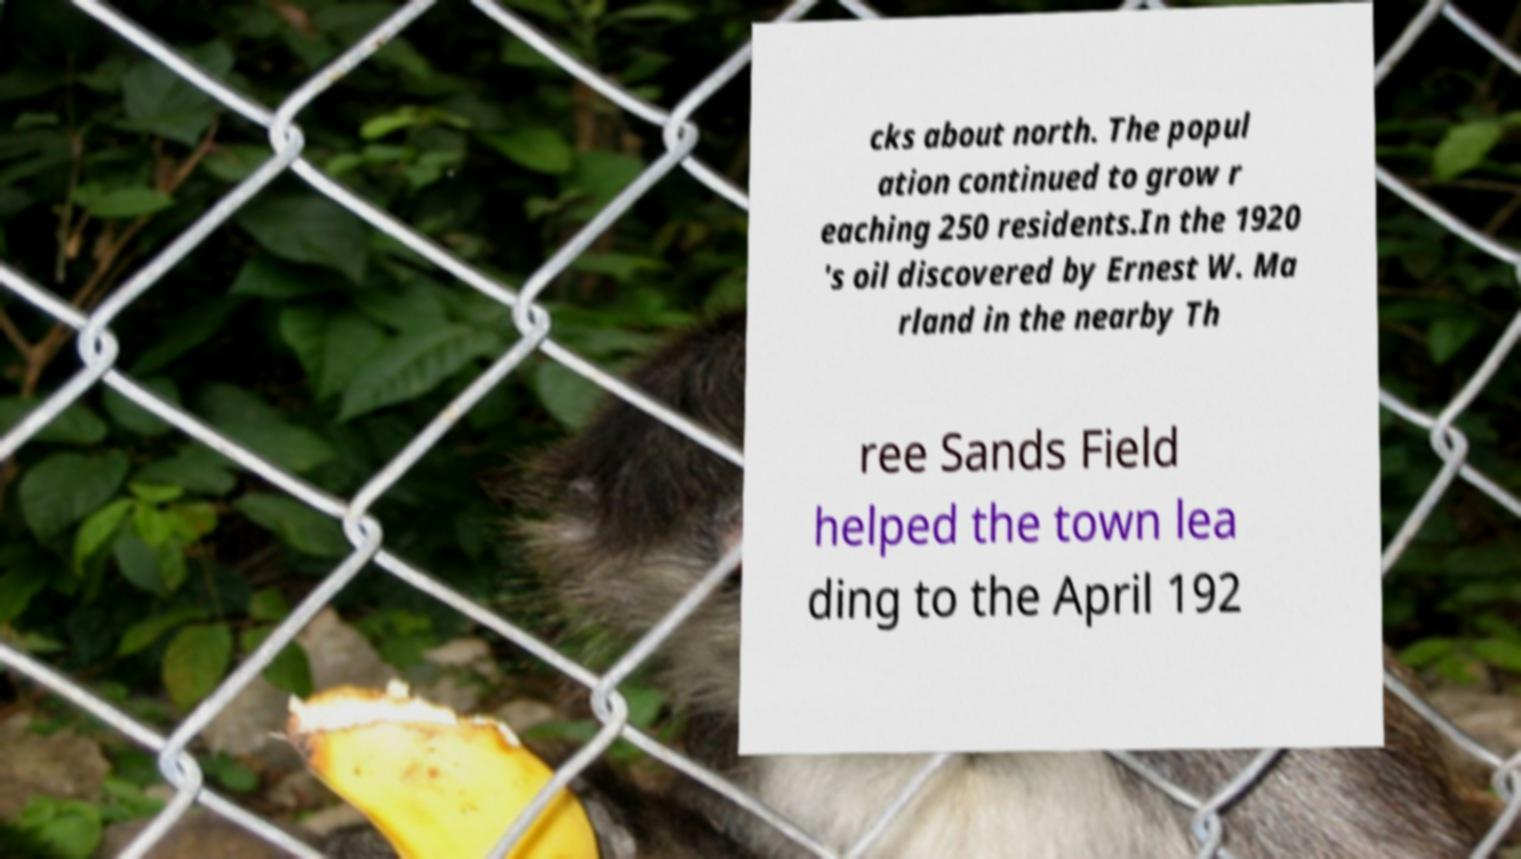Please read and relay the text visible in this image. What does it say? cks about north. The popul ation continued to grow r eaching 250 residents.In the 1920 's oil discovered by Ernest W. Ma rland in the nearby Th ree Sands Field helped the town lea ding to the April 192 